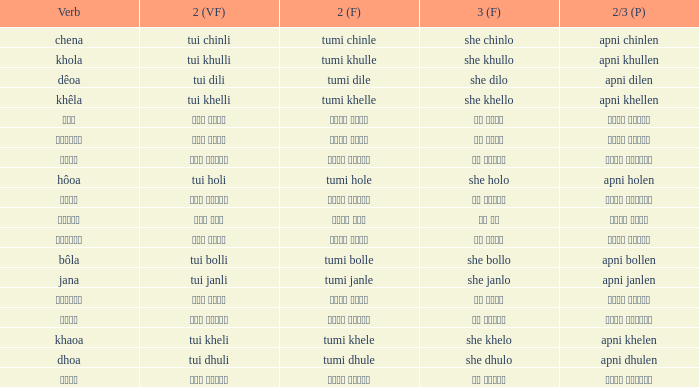What is the verb for তুমি খেলে? খাওয়া. Can you parse all the data within this table? {'header': ['Verb', '2 (VF)', '2 (F)', '3 (F)', '2/3 (P)'], 'rows': [['chena', 'tui chinli', 'tumi chinle', 'she chinlo', 'apni chinlen'], ['khola', 'tui khulli', 'tumi khulle', 'she khullo', 'apni khullen'], ['dêoa', 'tui dili', 'tumi dile', 'she dilo', 'apni dilen'], ['khêla', 'tui khelli', 'tumi khelle', 'she khello', 'apni khellen'], ['বলা', 'তুই বললি', 'তুমি বললে', 'সে বললো', 'আপনি বললেন'], ['খাওয়া', 'তুই খেলি', 'তুমি খেলে', 'সে খেলো', 'আপনি খেলেন'], ['জানা', 'তুই জানলি', 'তুমি জানলে', 'সে জানলে', 'আপনি জানলেন'], ['hôoa', 'tui holi', 'tumi hole', 'she holo', 'apni holen'], ['খেলে', 'তুই খেললি', 'তুমি খেললে', 'সে খেললো', 'আপনি খেললেন'], ['হওয়া', 'তুই হলি', 'তুমি হলে', 'সে হল', 'আপনি হলেন'], ['ধোওয়া', 'তুই ধুলি', 'তুমি ধুলে', 'সে ধুলো', 'আপনি ধুলেন'], ['bôla', 'tui bolli', 'tumi bolle', 'she bollo', 'apni bollen'], ['jana', 'tui janli', 'tumi janle', 'she janlo', 'apni janlen'], ['দেওয়া', 'তুই দিলি', 'তুমি দিলে', 'সে দিলো', 'আপনি দিলেন'], ['চেনা', 'তুই চিনলি', 'তুমি চিনলে', 'সে চিনলো', 'আপনি চিনলেন'], ['khaoa', 'tui kheli', 'tumi khele', 'she khelo', 'apni khelen'], ['dhoa', 'tui dhuli', 'tumi dhule', 'she dhulo', 'apni dhulen'], ['খোলা', 'তুই খুললি', 'তুমি খুললে', 'সে খুললো', 'আপনি খুললেন']]} 